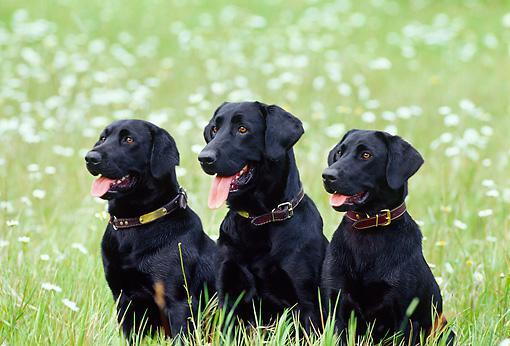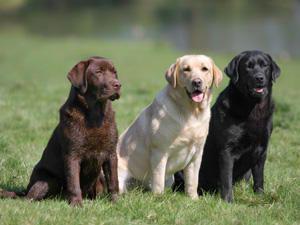The first image is the image on the left, the second image is the image on the right. Examine the images to the left and right. Is the description "One image includes exactly two dogs of different colors, and the other features a single dog." accurate? Answer yes or no. No. The first image is the image on the left, the second image is the image on the right. Considering the images on both sides, is "The right image contains at least three dogs." valid? Answer yes or no. Yes. 